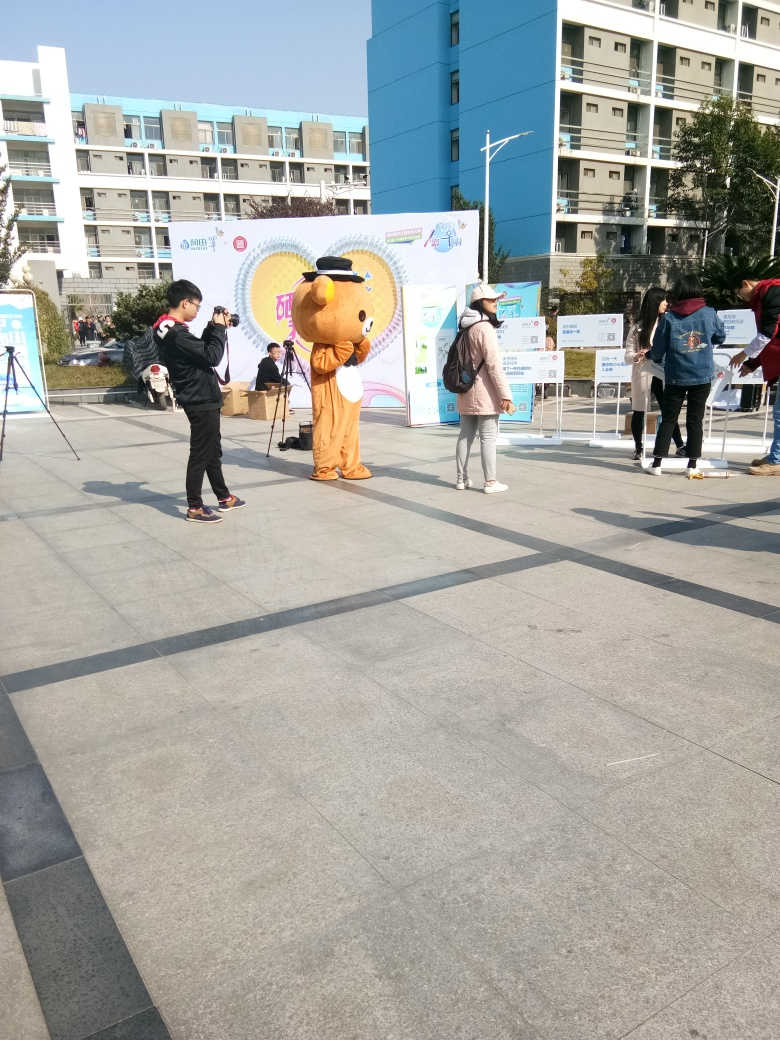What kind of weather does the image suggest? The shadows on the ground and bright sunlight suggest that the weather is clear and sunny. The attire of the people, which includes light, casual clothing, further implies that the temperature is likely comfortable, suited for an outdoor event. 